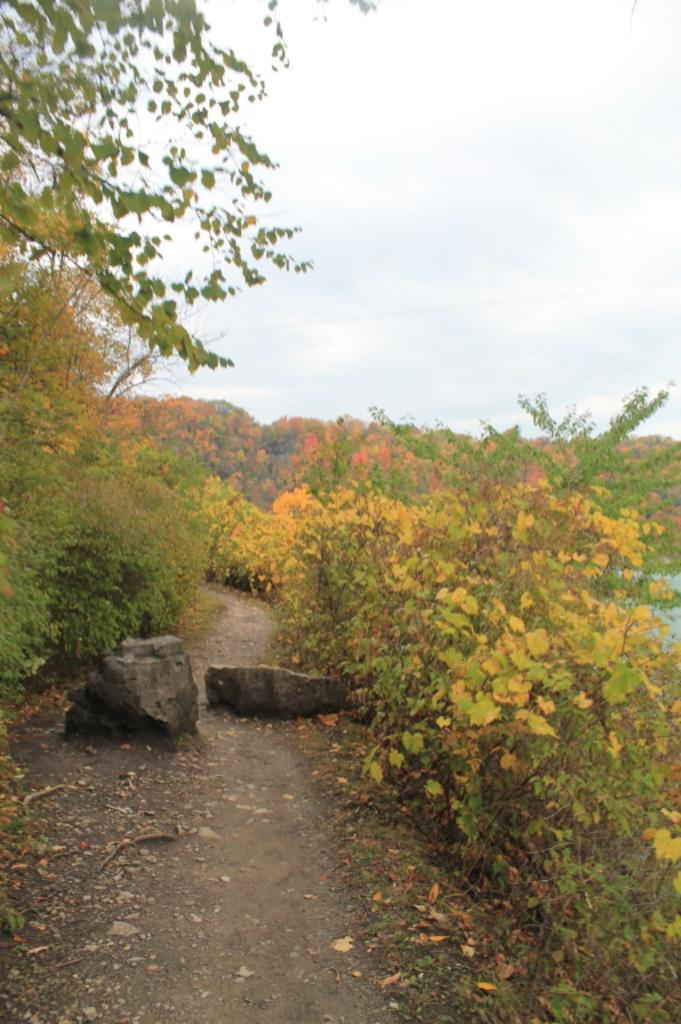What type of vegetation can be seen in the image? There are plants and trees in the image. What kind of path is present in the image? There is a walkway in the image. What is visible in the background of the image? The sky is visible in the background of the image. What material is used for the walkway in the image? There are stones on the walkway. What grade of friction is present between the stones on the walkway in the image? The facts provided do not give information about the grade of friction between the stones on the walkway. This detail cannot be determined from the image. 